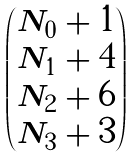Convert formula to latex. <formula><loc_0><loc_0><loc_500><loc_500>\begin{pmatrix} N _ { 0 } + 1 \\ N _ { 1 } + 4 \\ N _ { 2 } + 6 \\ N _ { 3 } + 3 \end{pmatrix}</formula> 